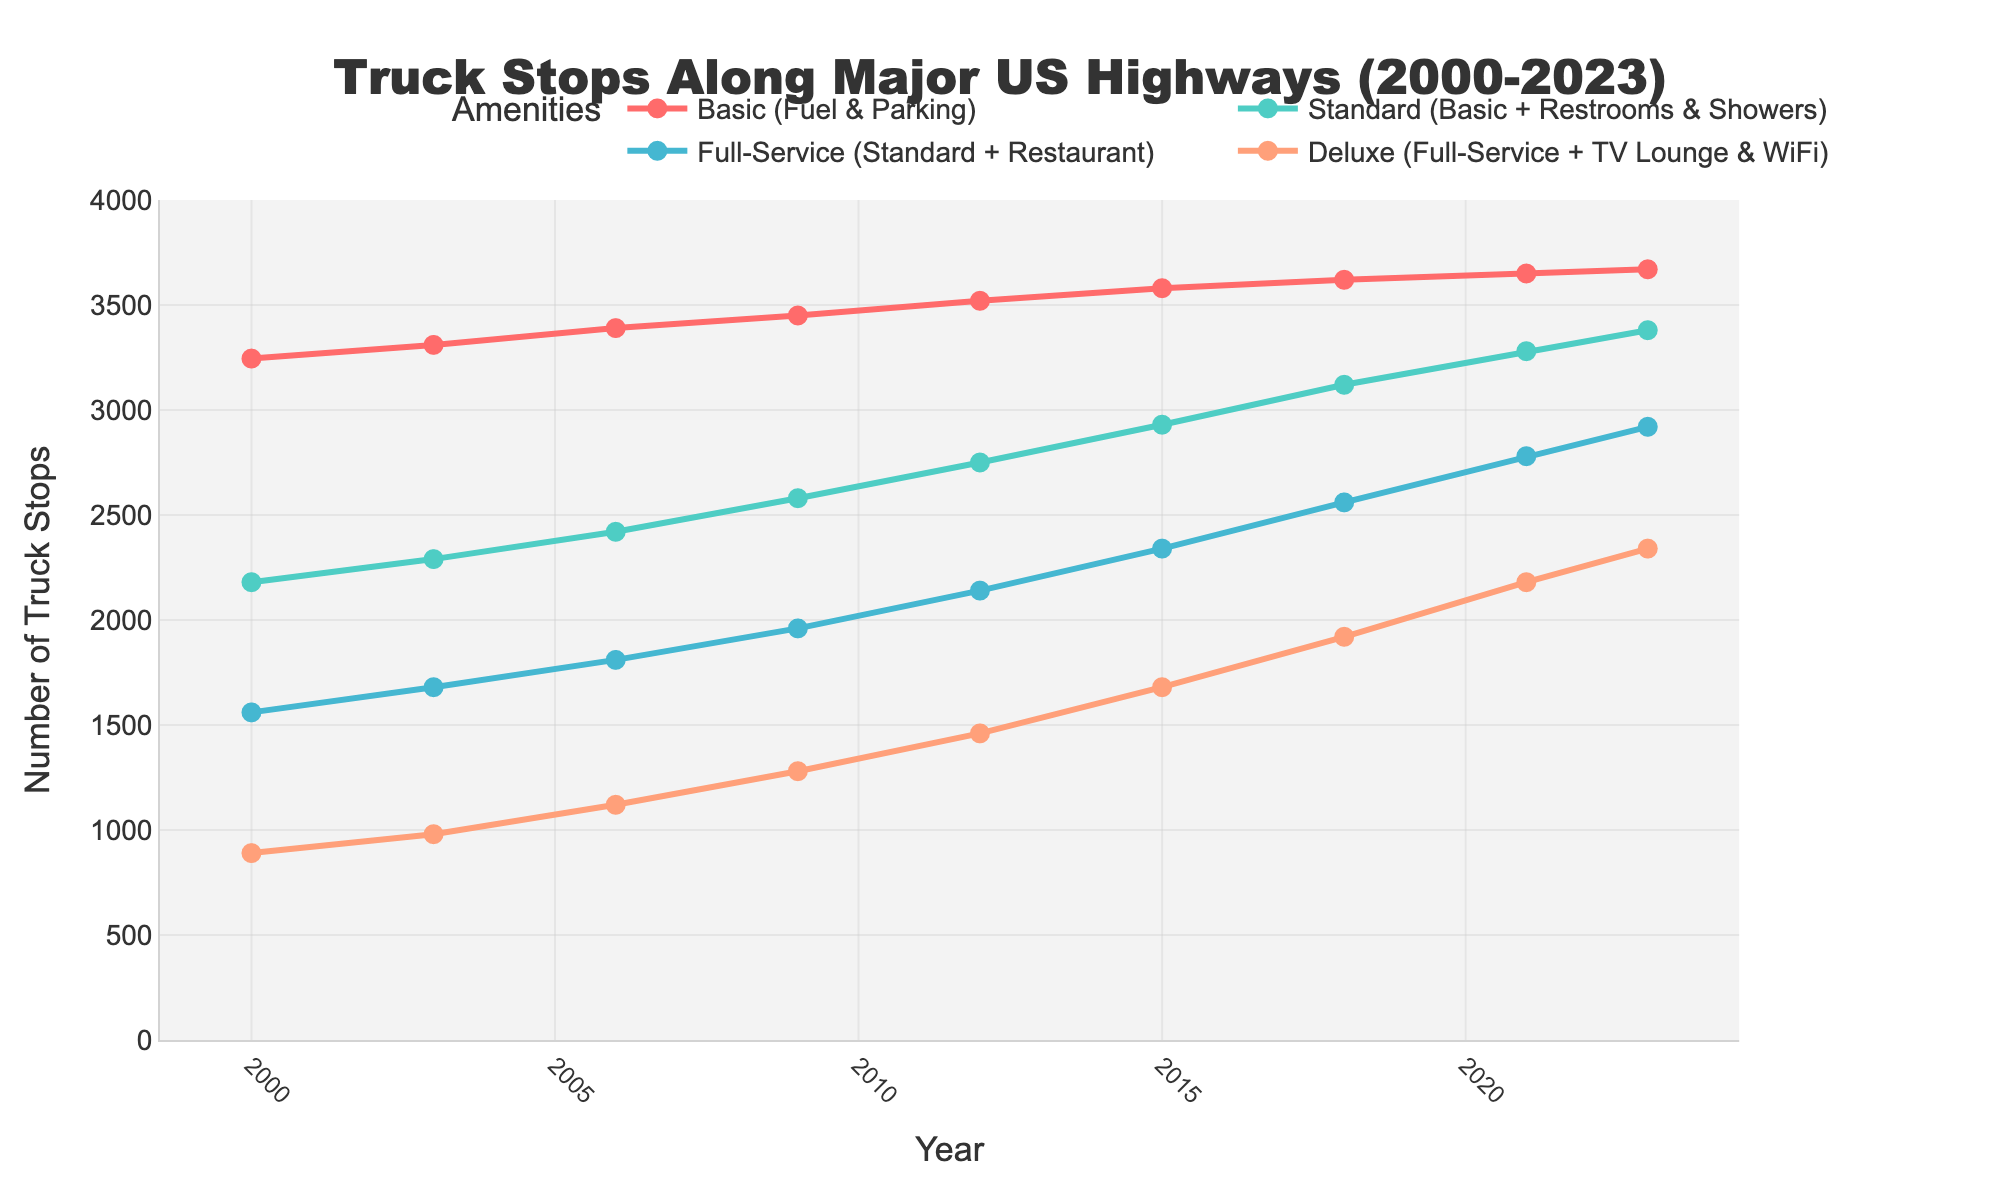Which category had the highest number of truck stops in 2023? To determine this, look at the values for each category in the year 2023. The category with the highest number is the one with the largest y-value.
Answer: Basic (Fuel & Parking) How did the number of Full-Service truck stops change from 2012 to 2023? Identify the values for Full-Service truck stops in 2012 and 2023. The difference between these values shows the change. 2920 - 2140 = 780
Answer: Increased by 780 Between which two consecutive years did Deluxe (Full-Service + TV Lounge & WiFi) truck stops see the largest increase? Check the yearly increments of the Deluxe category. Calculate the differences for each year range, and identify the largest increase. The difference between 2009 and 2012 is the largest: 1460 - 1280 = 180
Answer: Between 2009 and 2012 Which category shows a constant (no decrease) growth pattern throughout the years? Review the trends for each category. The category without any year showing a decrease compared to the previous year shows constant growth.
Answer: Basic (Fuel & Parking) By how much did the number of Standard (Basic + Restrooms & Showers) truck stops increase on average per year from 2000 to 2023? Calculate the total increase for Standard from 2000 to 2023: 3380 - 2180 = 1200. Then, divide by the number of years: 1200 / 23 ≈ 52.17
Answer: ~52.17 per year Compare the total number of truck stops in each category in 2015. Which had the smallest number? Check the values for each category in 2015 and compare them. The category with the smallest value has the least truck stops. 1680 (Deluxe)
Answer: Deluxe (Full-Service + TV Lounge & WiFi) How much was the difference in the number of truck stops between Basic (Fuel & Parking) and Full-Service (Standard + Restaurant) in the year 2006? Subtract the number of Full-Service stops from the number of Basic stops in 2006: 3390 - 1810 = 1580
Answer: 1580 What trends can you observe in Deluxe truck stops between 2000 and 2023? Review the data points for Deluxe over the years, observing its overall pattern. It shows a consistent increase over the years without any drop.
Answer: Consistent increase Which year saw the highest number of Standard truck stops between 2000 and 2023? Look at the y-values for Standard and identify the year with the maximum value.
Answer: 2023 From 2009 to 2023, did Basic truck stops or Deluxe truck stops see a greater absolute change in number? Calculate the change in numbers for each: Basic from 3450 to 3670 (3670 - 3450 = 220), Deluxe from 1280 to 2340 (2340 - 1280 = 1060). Compare the two changes.
Answer: Deluxe 